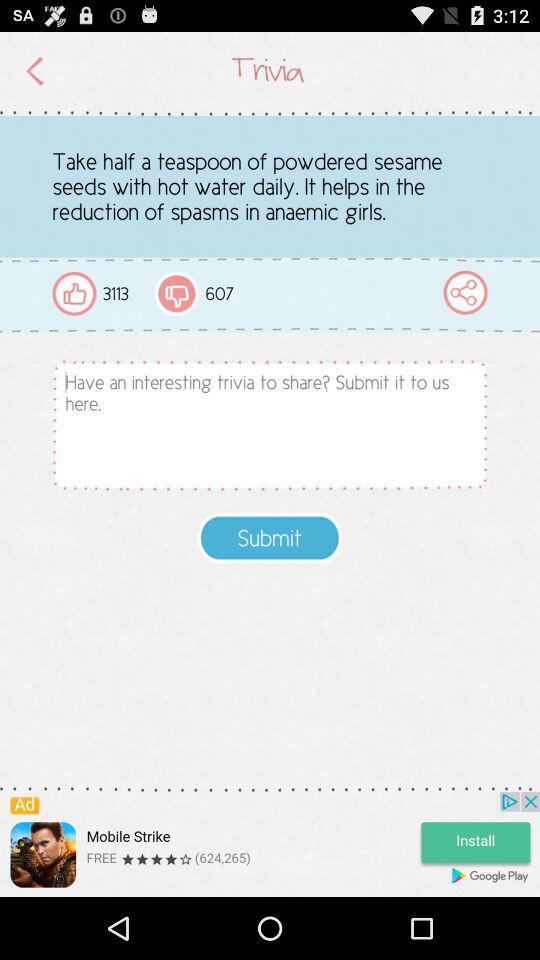How many likes are there? There are 3113 likes. 